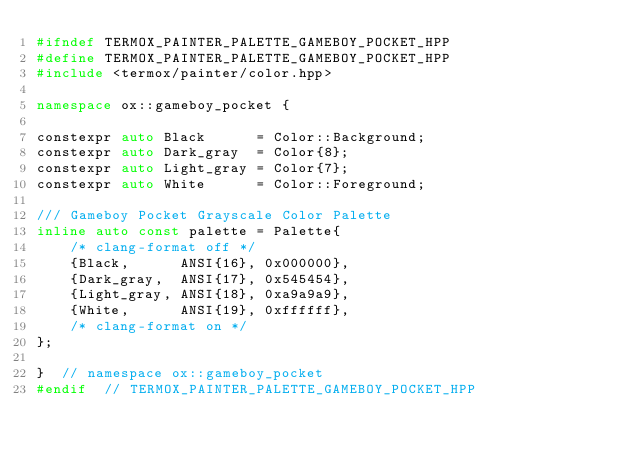Convert code to text. <code><loc_0><loc_0><loc_500><loc_500><_C++_>#ifndef TERMOX_PAINTER_PALETTE_GAMEBOY_POCKET_HPP
#define TERMOX_PAINTER_PALETTE_GAMEBOY_POCKET_HPP
#include <termox/painter/color.hpp>

namespace ox::gameboy_pocket {

constexpr auto Black      = Color::Background;
constexpr auto Dark_gray  = Color{8};
constexpr auto Light_gray = Color{7};
constexpr auto White      = Color::Foreground;

/// Gameboy Pocket Grayscale Color Palette
inline auto const palette = Palette{
    /* clang-format off */
    {Black,      ANSI{16}, 0x000000},
    {Dark_gray,  ANSI{17}, 0x545454},
    {Light_gray, ANSI{18}, 0xa9a9a9},
    {White,      ANSI{19}, 0xffffff},
    /* clang-format on */
};

}  // namespace ox::gameboy_pocket
#endif  // TERMOX_PAINTER_PALETTE_GAMEBOY_POCKET_HPP
</code> 